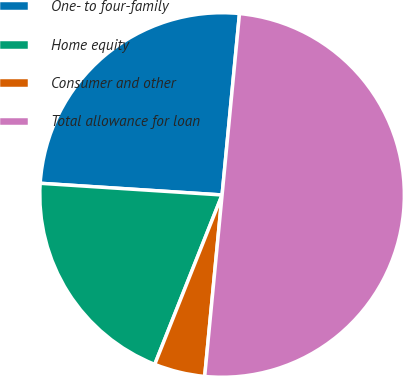Convert chart. <chart><loc_0><loc_0><loc_500><loc_500><pie_chart><fcel>One- to four-family<fcel>Home equity<fcel>Consumer and other<fcel>Total allowance for loan<nl><fcel>25.5%<fcel>20.0%<fcel>4.5%<fcel>50.0%<nl></chart> 